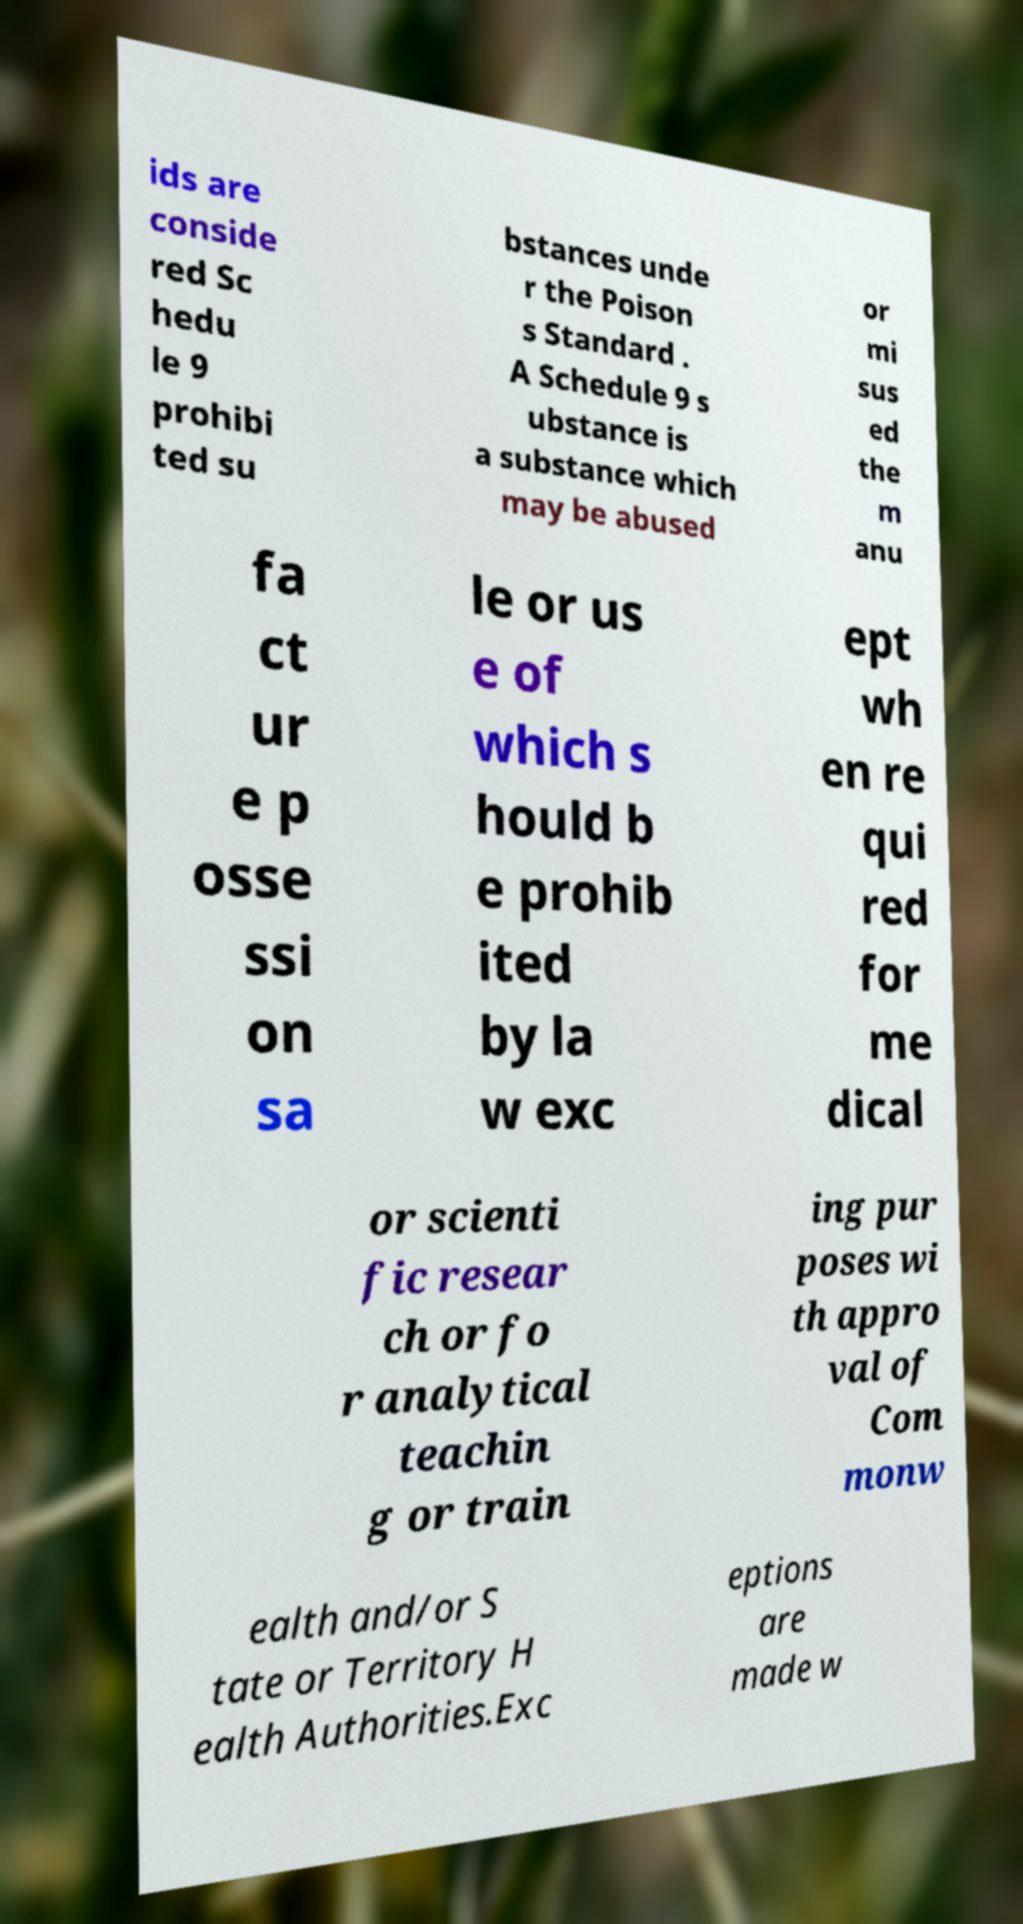Could you assist in decoding the text presented in this image and type it out clearly? ids are conside red Sc hedu le 9 prohibi ted su bstances unde r the Poison s Standard . A Schedule 9 s ubstance is a substance which may be abused or mi sus ed the m anu fa ct ur e p osse ssi on sa le or us e of which s hould b e prohib ited by la w exc ept wh en re qui red for me dical or scienti fic resear ch or fo r analytical teachin g or train ing pur poses wi th appro val of Com monw ealth and/or S tate or Territory H ealth Authorities.Exc eptions are made w 